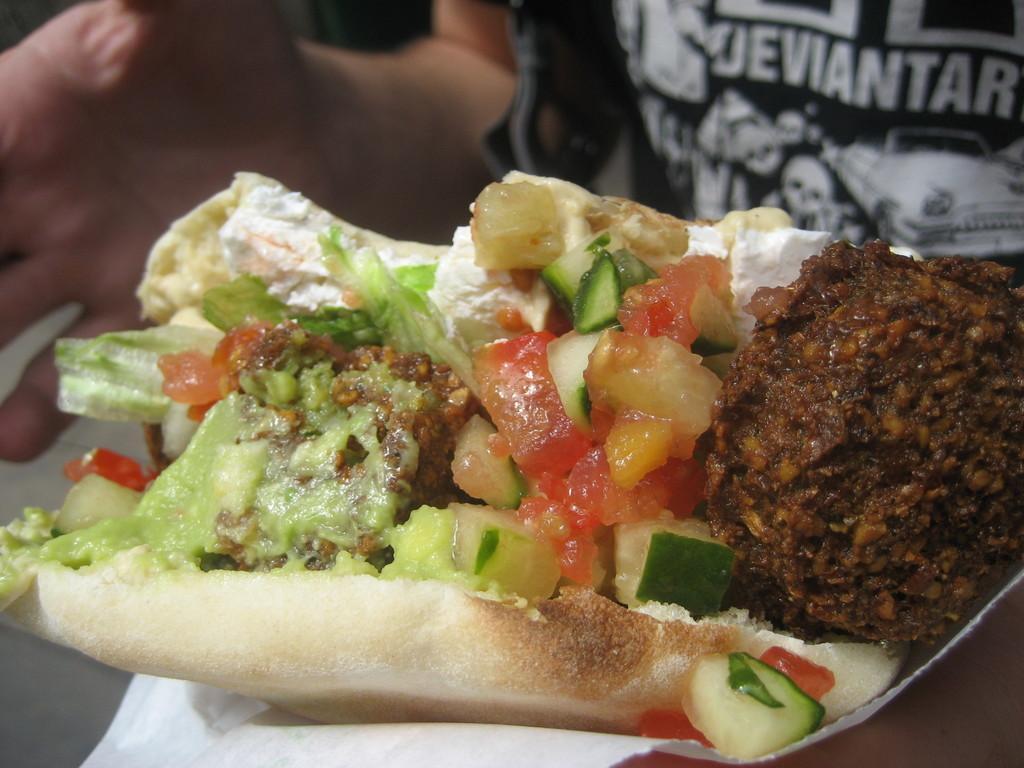Could you give a brief overview of what you see in this image? In this picture there is a person with black t-shirt is holding the food with the tissue and there is a text on the t-shirt. 